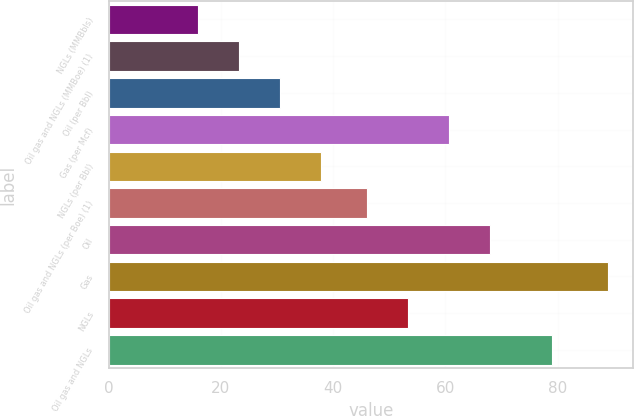<chart> <loc_0><loc_0><loc_500><loc_500><bar_chart><fcel>NGLs (MMBbls)<fcel>Oil gas and NGLs (MMBoe) (1)<fcel>Oil (per Bbl)<fcel>Gas (per Mcf)<fcel>NGLs (per Bbl)<fcel>Oil gas and NGLs (per Boe) (1)<fcel>Oil<fcel>Gas<fcel>NGLs<fcel>Oil gas and NGLs<nl><fcel>16<fcel>23.3<fcel>30.6<fcel>60.6<fcel>37.9<fcel>46<fcel>67.9<fcel>89<fcel>53.3<fcel>79<nl></chart> 